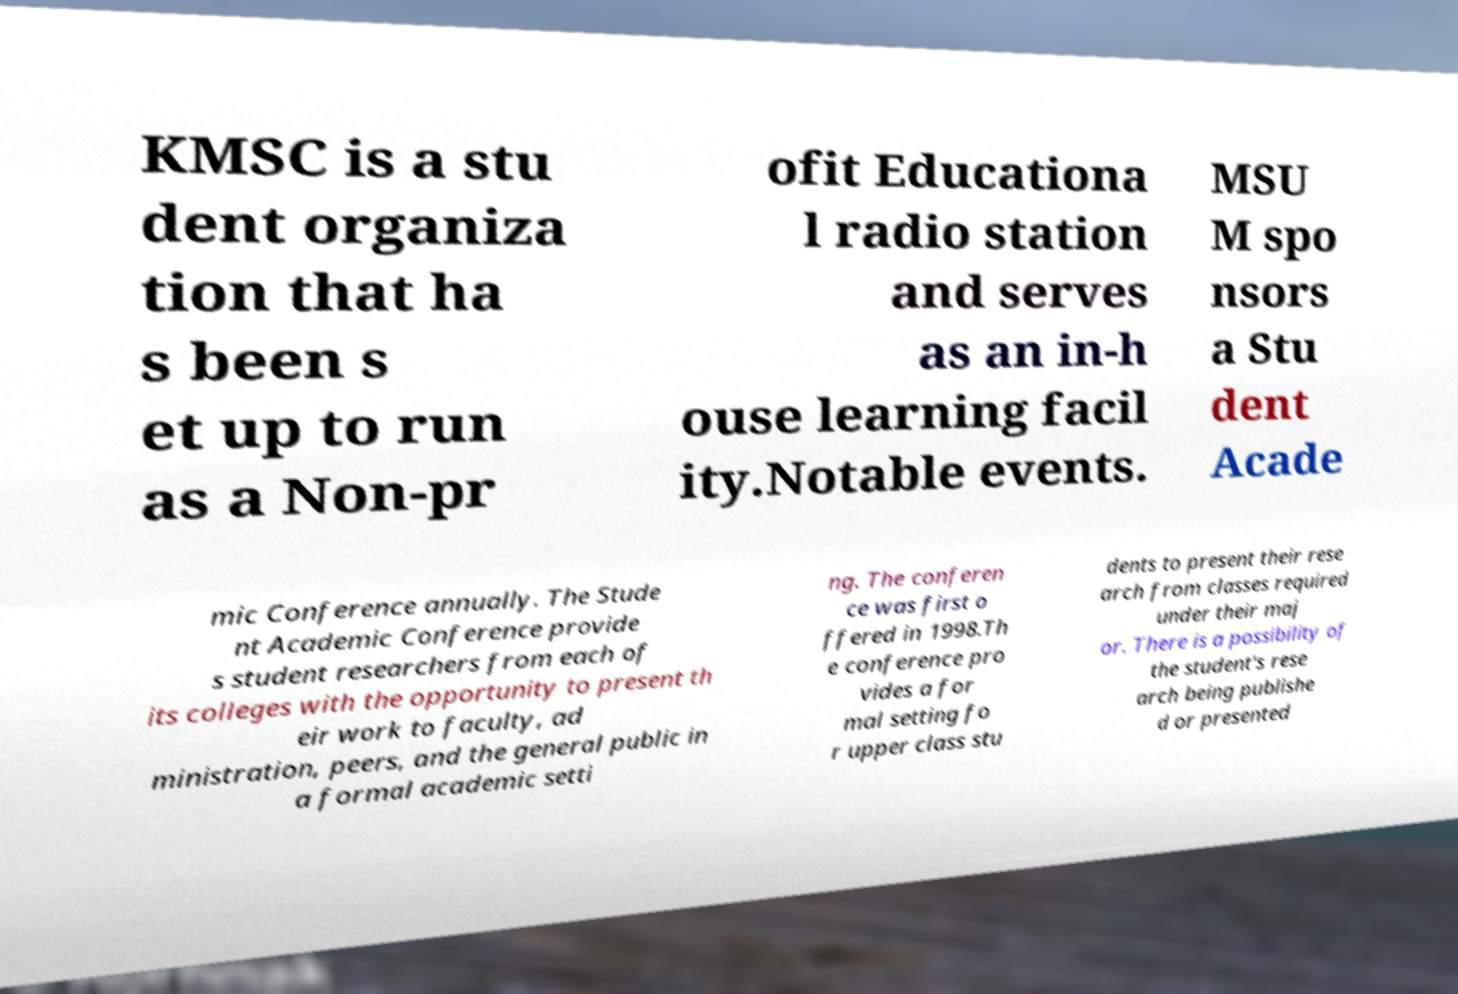For documentation purposes, I need the text within this image transcribed. Could you provide that? KMSC is a stu dent organiza tion that ha s been s et up to run as a Non-pr ofit Educationa l radio station and serves as an in-h ouse learning facil ity.Notable events. MSU M spo nsors a Stu dent Acade mic Conference annually. The Stude nt Academic Conference provide s student researchers from each of its colleges with the opportunity to present th eir work to faculty, ad ministration, peers, and the general public in a formal academic setti ng. The conferen ce was first o ffered in 1998.Th e conference pro vides a for mal setting fo r upper class stu dents to present their rese arch from classes required under their maj or. There is a possibility of the student's rese arch being publishe d or presented 